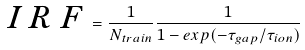Convert formula to latex. <formula><loc_0><loc_0><loc_500><loc_500>\emph { I R F } = \frac { 1 } { N _ { t r a i n } } { \frac { 1 } { 1 - e x p ( - { \tau } _ { g a p } / { \tau } _ { i o n } ) } }</formula> 